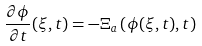Convert formula to latex. <formula><loc_0><loc_0><loc_500><loc_500>\frac { \partial \phi } { \partial t } ( \xi , t ) = - \Xi _ { a } \left ( \phi ( \xi , t ) , t \right )</formula> 